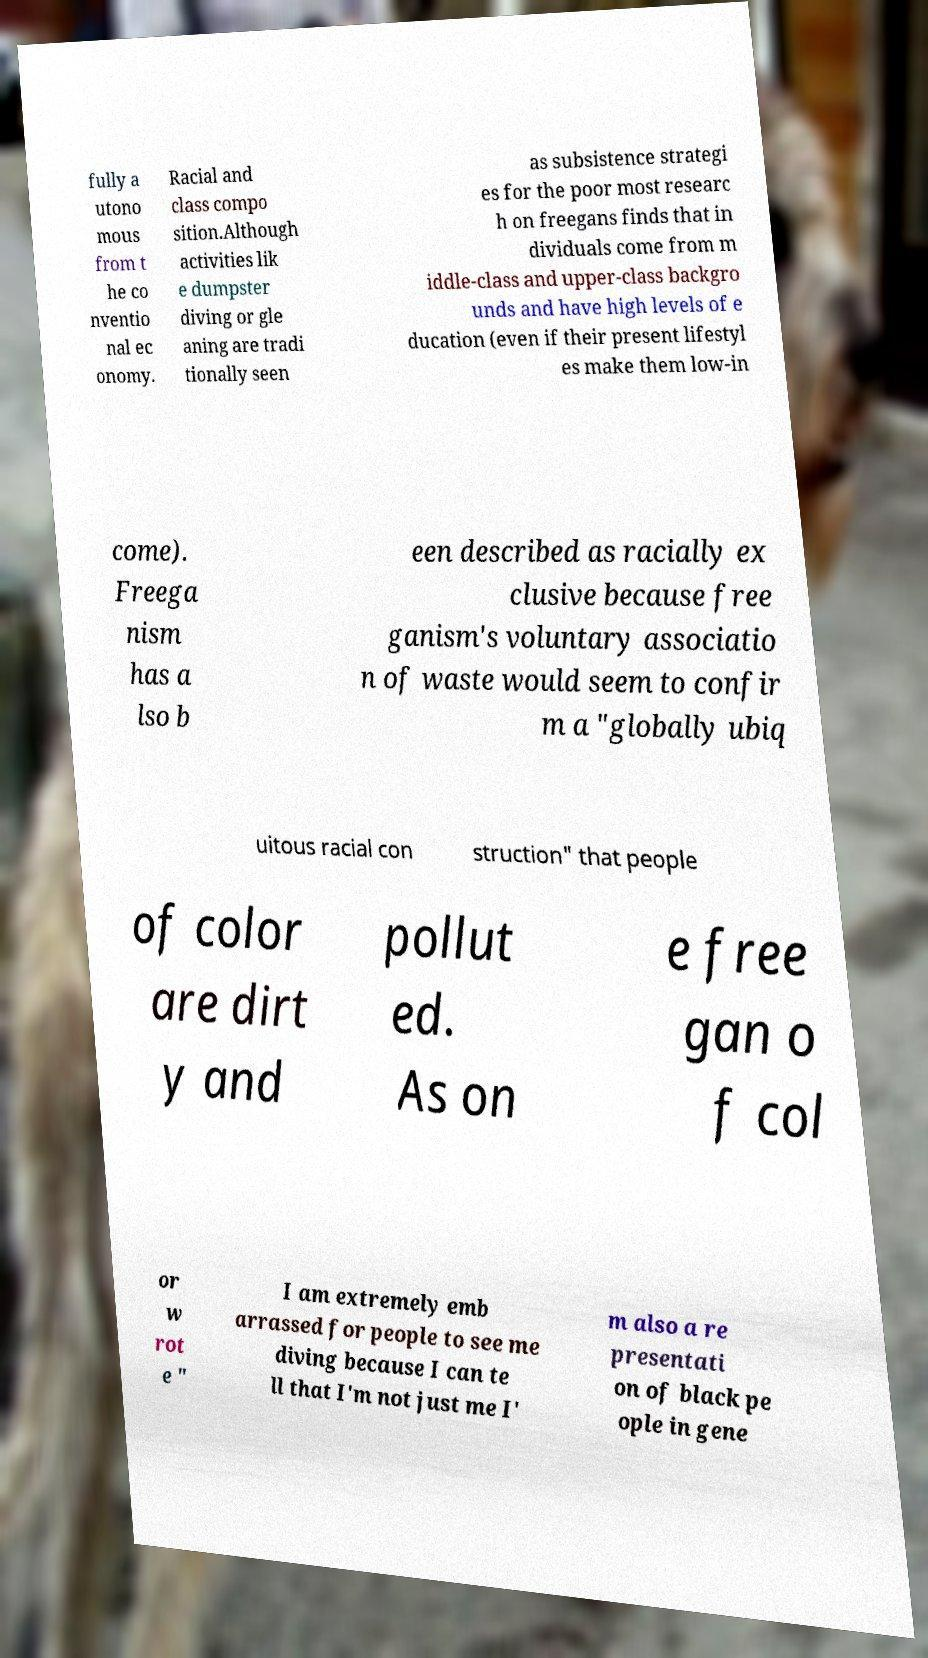Can you read and provide the text displayed in the image?This photo seems to have some interesting text. Can you extract and type it out for me? fully a utono mous from t he co nventio nal ec onomy. Racial and class compo sition.Although activities lik e dumpster diving or gle aning are tradi tionally seen as subsistence strategi es for the poor most researc h on freegans finds that in dividuals come from m iddle-class and upper-class backgro unds and have high levels of e ducation (even if their present lifestyl es make them low-in come). Freega nism has a lso b een described as racially ex clusive because free ganism's voluntary associatio n of waste would seem to confir m a "globally ubiq uitous racial con struction" that people of color are dirt y and pollut ed. As on e free gan o f col or w rot e " I am extremely emb arrassed for people to see me diving because I can te ll that I'm not just me I' m also a re presentati on of black pe ople in gene 